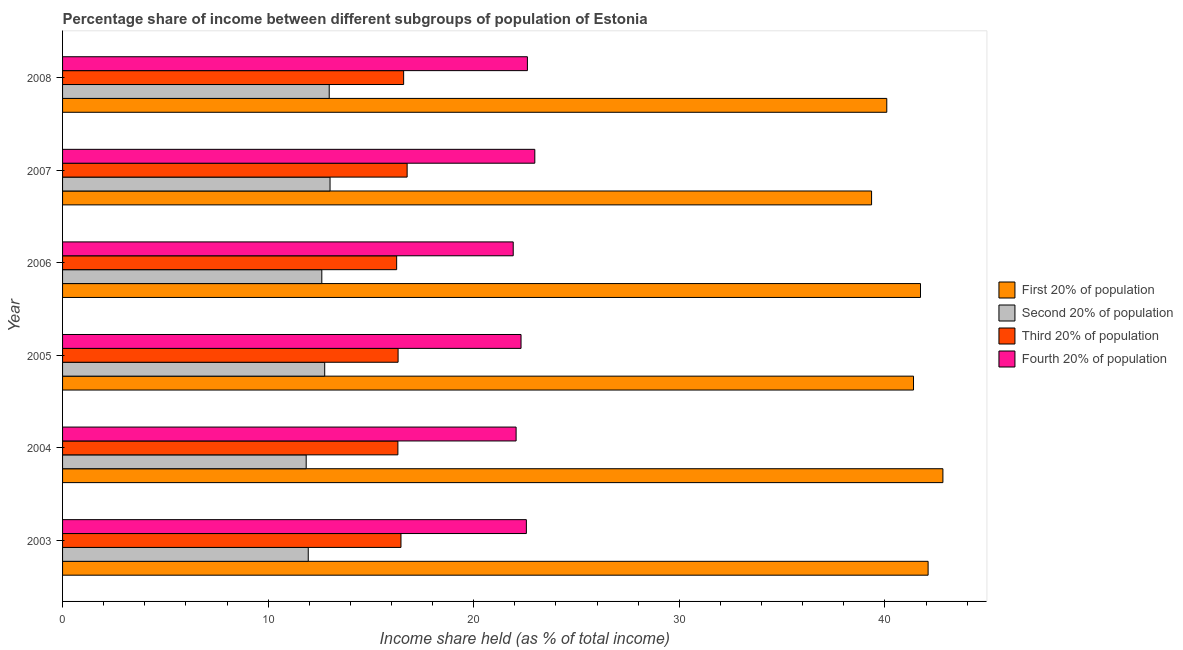Are the number of bars on each tick of the Y-axis equal?
Ensure brevity in your answer.  Yes. How many bars are there on the 1st tick from the top?
Offer a terse response. 4. How many bars are there on the 5th tick from the bottom?
Offer a terse response. 4. What is the label of the 4th group of bars from the top?
Offer a terse response. 2005. In how many cases, is the number of bars for a given year not equal to the number of legend labels?
Offer a very short reply. 0. What is the share of the income held by fourth 20% of the population in 2003?
Your response must be concise. 22.56. Across all years, what is the maximum share of the income held by fourth 20% of the population?
Offer a very short reply. 22.97. Across all years, what is the minimum share of the income held by third 20% of the population?
Make the answer very short. 16.25. In which year was the share of the income held by second 20% of the population maximum?
Your answer should be very brief. 2007. What is the total share of the income held by first 20% of the population in the graph?
Your answer should be compact. 247.48. What is the difference between the share of the income held by first 20% of the population in 2005 and the share of the income held by second 20% of the population in 2004?
Ensure brevity in your answer.  29.54. What is the average share of the income held by second 20% of the population per year?
Your response must be concise. 12.52. In the year 2003, what is the difference between the share of the income held by third 20% of the population and share of the income held by second 20% of the population?
Provide a short and direct response. 4.51. In how many years, is the share of the income held by second 20% of the population greater than 18 %?
Your answer should be very brief. 0. Is the share of the income held by first 20% of the population in 2003 less than that in 2006?
Your answer should be very brief. No. What is the difference between the highest and the second highest share of the income held by second 20% of the population?
Keep it short and to the point. 0.04. What is the difference between the highest and the lowest share of the income held by third 20% of the population?
Ensure brevity in your answer.  0.51. In how many years, is the share of the income held by fourth 20% of the population greater than the average share of the income held by fourth 20% of the population taken over all years?
Offer a very short reply. 3. Is the sum of the share of the income held by second 20% of the population in 2004 and 2005 greater than the maximum share of the income held by first 20% of the population across all years?
Your response must be concise. No. Is it the case that in every year, the sum of the share of the income held by second 20% of the population and share of the income held by first 20% of the population is greater than the sum of share of the income held by fourth 20% of the population and share of the income held by third 20% of the population?
Offer a terse response. Yes. What does the 3rd bar from the top in 2008 represents?
Ensure brevity in your answer.  Second 20% of population. What does the 3rd bar from the bottom in 2006 represents?
Ensure brevity in your answer.  Third 20% of population. Is it the case that in every year, the sum of the share of the income held by first 20% of the population and share of the income held by second 20% of the population is greater than the share of the income held by third 20% of the population?
Your answer should be very brief. Yes. Are the values on the major ticks of X-axis written in scientific E-notation?
Keep it short and to the point. No. Does the graph contain grids?
Provide a short and direct response. No. How many legend labels are there?
Your response must be concise. 4. How are the legend labels stacked?
Give a very brief answer. Vertical. What is the title of the graph?
Offer a terse response. Percentage share of income between different subgroups of population of Estonia. Does "Goods and services" appear as one of the legend labels in the graph?
Your answer should be very brief. No. What is the label or title of the X-axis?
Provide a short and direct response. Income share held (as % of total income). What is the Income share held (as % of total income) in First 20% of population in 2003?
Provide a short and direct response. 42.1. What is the Income share held (as % of total income) in Second 20% of population in 2003?
Make the answer very short. 11.95. What is the Income share held (as % of total income) in Third 20% of population in 2003?
Your answer should be compact. 16.46. What is the Income share held (as % of total income) in Fourth 20% of population in 2003?
Offer a very short reply. 22.56. What is the Income share held (as % of total income) in First 20% of population in 2004?
Your response must be concise. 42.82. What is the Income share held (as % of total income) of Second 20% of population in 2004?
Keep it short and to the point. 11.85. What is the Income share held (as % of total income) in Third 20% of population in 2004?
Provide a short and direct response. 16.31. What is the Income share held (as % of total income) of Fourth 20% of population in 2004?
Offer a very short reply. 22.06. What is the Income share held (as % of total income) in First 20% of population in 2005?
Provide a short and direct response. 41.39. What is the Income share held (as % of total income) of Second 20% of population in 2005?
Make the answer very short. 12.75. What is the Income share held (as % of total income) of Third 20% of population in 2005?
Provide a short and direct response. 16.32. What is the Income share held (as % of total income) in Fourth 20% of population in 2005?
Your response must be concise. 22.3. What is the Income share held (as % of total income) in First 20% of population in 2006?
Your response must be concise. 41.73. What is the Income share held (as % of total income) of Second 20% of population in 2006?
Make the answer very short. 12.61. What is the Income share held (as % of total income) of Third 20% of population in 2006?
Make the answer very short. 16.25. What is the Income share held (as % of total income) of Fourth 20% of population in 2006?
Ensure brevity in your answer.  21.92. What is the Income share held (as % of total income) of First 20% of population in 2007?
Ensure brevity in your answer.  39.35. What is the Income share held (as % of total income) in Second 20% of population in 2007?
Offer a very short reply. 13.01. What is the Income share held (as % of total income) of Third 20% of population in 2007?
Your response must be concise. 16.76. What is the Income share held (as % of total income) in Fourth 20% of population in 2007?
Make the answer very short. 22.97. What is the Income share held (as % of total income) of First 20% of population in 2008?
Give a very brief answer. 40.09. What is the Income share held (as % of total income) in Second 20% of population in 2008?
Keep it short and to the point. 12.97. What is the Income share held (as % of total income) of Third 20% of population in 2008?
Your answer should be compact. 16.59. What is the Income share held (as % of total income) of Fourth 20% of population in 2008?
Provide a succinct answer. 22.61. Across all years, what is the maximum Income share held (as % of total income) in First 20% of population?
Your answer should be very brief. 42.82. Across all years, what is the maximum Income share held (as % of total income) in Second 20% of population?
Ensure brevity in your answer.  13.01. Across all years, what is the maximum Income share held (as % of total income) in Third 20% of population?
Your response must be concise. 16.76. Across all years, what is the maximum Income share held (as % of total income) in Fourth 20% of population?
Ensure brevity in your answer.  22.97. Across all years, what is the minimum Income share held (as % of total income) of First 20% of population?
Ensure brevity in your answer.  39.35. Across all years, what is the minimum Income share held (as % of total income) in Second 20% of population?
Provide a short and direct response. 11.85. Across all years, what is the minimum Income share held (as % of total income) in Third 20% of population?
Ensure brevity in your answer.  16.25. Across all years, what is the minimum Income share held (as % of total income) of Fourth 20% of population?
Keep it short and to the point. 21.92. What is the total Income share held (as % of total income) in First 20% of population in the graph?
Your response must be concise. 247.48. What is the total Income share held (as % of total income) in Second 20% of population in the graph?
Offer a terse response. 75.14. What is the total Income share held (as % of total income) in Third 20% of population in the graph?
Make the answer very short. 98.69. What is the total Income share held (as % of total income) in Fourth 20% of population in the graph?
Your answer should be very brief. 134.42. What is the difference between the Income share held (as % of total income) of First 20% of population in 2003 and that in 2004?
Your response must be concise. -0.72. What is the difference between the Income share held (as % of total income) of Fourth 20% of population in 2003 and that in 2004?
Ensure brevity in your answer.  0.5. What is the difference between the Income share held (as % of total income) of First 20% of population in 2003 and that in 2005?
Give a very brief answer. 0.71. What is the difference between the Income share held (as % of total income) of Second 20% of population in 2003 and that in 2005?
Make the answer very short. -0.8. What is the difference between the Income share held (as % of total income) in Third 20% of population in 2003 and that in 2005?
Make the answer very short. 0.14. What is the difference between the Income share held (as % of total income) of Fourth 20% of population in 2003 and that in 2005?
Offer a very short reply. 0.26. What is the difference between the Income share held (as % of total income) in First 20% of population in 2003 and that in 2006?
Your answer should be very brief. 0.37. What is the difference between the Income share held (as % of total income) of Second 20% of population in 2003 and that in 2006?
Provide a succinct answer. -0.66. What is the difference between the Income share held (as % of total income) in Third 20% of population in 2003 and that in 2006?
Give a very brief answer. 0.21. What is the difference between the Income share held (as % of total income) in Fourth 20% of population in 2003 and that in 2006?
Ensure brevity in your answer.  0.64. What is the difference between the Income share held (as % of total income) of First 20% of population in 2003 and that in 2007?
Make the answer very short. 2.75. What is the difference between the Income share held (as % of total income) in Second 20% of population in 2003 and that in 2007?
Ensure brevity in your answer.  -1.06. What is the difference between the Income share held (as % of total income) in Third 20% of population in 2003 and that in 2007?
Your answer should be very brief. -0.3. What is the difference between the Income share held (as % of total income) in Fourth 20% of population in 2003 and that in 2007?
Your response must be concise. -0.41. What is the difference between the Income share held (as % of total income) of First 20% of population in 2003 and that in 2008?
Your response must be concise. 2.01. What is the difference between the Income share held (as % of total income) in Second 20% of population in 2003 and that in 2008?
Make the answer very short. -1.02. What is the difference between the Income share held (as % of total income) of Third 20% of population in 2003 and that in 2008?
Offer a terse response. -0.13. What is the difference between the Income share held (as % of total income) in First 20% of population in 2004 and that in 2005?
Make the answer very short. 1.43. What is the difference between the Income share held (as % of total income) in Second 20% of population in 2004 and that in 2005?
Offer a very short reply. -0.9. What is the difference between the Income share held (as % of total income) of Third 20% of population in 2004 and that in 2005?
Ensure brevity in your answer.  -0.01. What is the difference between the Income share held (as % of total income) in Fourth 20% of population in 2004 and that in 2005?
Provide a short and direct response. -0.24. What is the difference between the Income share held (as % of total income) in First 20% of population in 2004 and that in 2006?
Provide a succinct answer. 1.09. What is the difference between the Income share held (as % of total income) in Second 20% of population in 2004 and that in 2006?
Your answer should be compact. -0.76. What is the difference between the Income share held (as % of total income) in Third 20% of population in 2004 and that in 2006?
Your response must be concise. 0.06. What is the difference between the Income share held (as % of total income) of Fourth 20% of population in 2004 and that in 2006?
Your response must be concise. 0.14. What is the difference between the Income share held (as % of total income) in First 20% of population in 2004 and that in 2007?
Your answer should be compact. 3.47. What is the difference between the Income share held (as % of total income) of Second 20% of population in 2004 and that in 2007?
Make the answer very short. -1.16. What is the difference between the Income share held (as % of total income) in Third 20% of population in 2004 and that in 2007?
Your answer should be very brief. -0.45. What is the difference between the Income share held (as % of total income) in Fourth 20% of population in 2004 and that in 2007?
Your answer should be very brief. -0.91. What is the difference between the Income share held (as % of total income) in First 20% of population in 2004 and that in 2008?
Your answer should be compact. 2.73. What is the difference between the Income share held (as % of total income) in Second 20% of population in 2004 and that in 2008?
Your response must be concise. -1.12. What is the difference between the Income share held (as % of total income) of Third 20% of population in 2004 and that in 2008?
Make the answer very short. -0.28. What is the difference between the Income share held (as % of total income) of Fourth 20% of population in 2004 and that in 2008?
Ensure brevity in your answer.  -0.55. What is the difference between the Income share held (as % of total income) of First 20% of population in 2005 and that in 2006?
Your answer should be compact. -0.34. What is the difference between the Income share held (as % of total income) in Second 20% of population in 2005 and that in 2006?
Give a very brief answer. 0.14. What is the difference between the Income share held (as % of total income) of Third 20% of population in 2005 and that in 2006?
Your answer should be very brief. 0.07. What is the difference between the Income share held (as % of total income) in Fourth 20% of population in 2005 and that in 2006?
Provide a succinct answer. 0.38. What is the difference between the Income share held (as % of total income) of First 20% of population in 2005 and that in 2007?
Provide a succinct answer. 2.04. What is the difference between the Income share held (as % of total income) in Second 20% of population in 2005 and that in 2007?
Provide a succinct answer. -0.26. What is the difference between the Income share held (as % of total income) of Third 20% of population in 2005 and that in 2007?
Your response must be concise. -0.44. What is the difference between the Income share held (as % of total income) in Fourth 20% of population in 2005 and that in 2007?
Your answer should be compact. -0.67. What is the difference between the Income share held (as % of total income) of First 20% of population in 2005 and that in 2008?
Provide a short and direct response. 1.3. What is the difference between the Income share held (as % of total income) of Second 20% of population in 2005 and that in 2008?
Provide a succinct answer. -0.22. What is the difference between the Income share held (as % of total income) of Third 20% of population in 2005 and that in 2008?
Your response must be concise. -0.27. What is the difference between the Income share held (as % of total income) in Fourth 20% of population in 2005 and that in 2008?
Keep it short and to the point. -0.31. What is the difference between the Income share held (as % of total income) in First 20% of population in 2006 and that in 2007?
Provide a succinct answer. 2.38. What is the difference between the Income share held (as % of total income) in Third 20% of population in 2006 and that in 2007?
Provide a succinct answer. -0.51. What is the difference between the Income share held (as % of total income) in Fourth 20% of population in 2006 and that in 2007?
Ensure brevity in your answer.  -1.05. What is the difference between the Income share held (as % of total income) in First 20% of population in 2006 and that in 2008?
Your response must be concise. 1.64. What is the difference between the Income share held (as % of total income) of Second 20% of population in 2006 and that in 2008?
Your answer should be compact. -0.36. What is the difference between the Income share held (as % of total income) of Third 20% of population in 2006 and that in 2008?
Offer a very short reply. -0.34. What is the difference between the Income share held (as % of total income) in Fourth 20% of population in 2006 and that in 2008?
Your response must be concise. -0.69. What is the difference between the Income share held (as % of total income) of First 20% of population in 2007 and that in 2008?
Provide a short and direct response. -0.74. What is the difference between the Income share held (as % of total income) of Third 20% of population in 2007 and that in 2008?
Provide a short and direct response. 0.17. What is the difference between the Income share held (as % of total income) in Fourth 20% of population in 2007 and that in 2008?
Offer a very short reply. 0.36. What is the difference between the Income share held (as % of total income) of First 20% of population in 2003 and the Income share held (as % of total income) of Second 20% of population in 2004?
Provide a short and direct response. 30.25. What is the difference between the Income share held (as % of total income) of First 20% of population in 2003 and the Income share held (as % of total income) of Third 20% of population in 2004?
Make the answer very short. 25.79. What is the difference between the Income share held (as % of total income) of First 20% of population in 2003 and the Income share held (as % of total income) of Fourth 20% of population in 2004?
Offer a very short reply. 20.04. What is the difference between the Income share held (as % of total income) of Second 20% of population in 2003 and the Income share held (as % of total income) of Third 20% of population in 2004?
Make the answer very short. -4.36. What is the difference between the Income share held (as % of total income) in Second 20% of population in 2003 and the Income share held (as % of total income) in Fourth 20% of population in 2004?
Make the answer very short. -10.11. What is the difference between the Income share held (as % of total income) of Third 20% of population in 2003 and the Income share held (as % of total income) of Fourth 20% of population in 2004?
Give a very brief answer. -5.6. What is the difference between the Income share held (as % of total income) of First 20% of population in 2003 and the Income share held (as % of total income) of Second 20% of population in 2005?
Offer a terse response. 29.35. What is the difference between the Income share held (as % of total income) of First 20% of population in 2003 and the Income share held (as % of total income) of Third 20% of population in 2005?
Your answer should be very brief. 25.78. What is the difference between the Income share held (as % of total income) of First 20% of population in 2003 and the Income share held (as % of total income) of Fourth 20% of population in 2005?
Keep it short and to the point. 19.8. What is the difference between the Income share held (as % of total income) in Second 20% of population in 2003 and the Income share held (as % of total income) in Third 20% of population in 2005?
Ensure brevity in your answer.  -4.37. What is the difference between the Income share held (as % of total income) of Second 20% of population in 2003 and the Income share held (as % of total income) of Fourth 20% of population in 2005?
Provide a succinct answer. -10.35. What is the difference between the Income share held (as % of total income) of Third 20% of population in 2003 and the Income share held (as % of total income) of Fourth 20% of population in 2005?
Make the answer very short. -5.84. What is the difference between the Income share held (as % of total income) of First 20% of population in 2003 and the Income share held (as % of total income) of Second 20% of population in 2006?
Provide a short and direct response. 29.49. What is the difference between the Income share held (as % of total income) of First 20% of population in 2003 and the Income share held (as % of total income) of Third 20% of population in 2006?
Your response must be concise. 25.85. What is the difference between the Income share held (as % of total income) of First 20% of population in 2003 and the Income share held (as % of total income) of Fourth 20% of population in 2006?
Make the answer very short. 20.18. What is the difference between the Income share held (as % of total income) in Second 20% of population in 2003 and the Income share held (as % of total income) in Fourth 20% of population in 2006?
Your answer should be compact. -9.97. What is the difference between the Income share held (as % of total income) of Third 20% of population in 2003 and the Income share held (as % of total income) of Fourth 20% of population in 2006?
Provide a succinct answer. -5.46. What is the difference between the Income share held (as % of total income) in First 20% of population in 2003 and the Income share held (as % of total income) in Second 20% of population in 2007?
Offer a very short reply. 29.09. What is the difference between the Income share held (as % of total income) of First 20% of population in 2003 and the Income share held (as % of total income) of Third 20% of population in 2007?
Offer a terse response. 25.34. What is the difference between the Income share held (as % of total income) of First 20% of population in 2003 and the Income share held (as % of total income) of Fourth 20% of population in 2007?
Give a very brief answer. 19.13. What is the difference between the Income share held (as % of total income) of Second 20% of population in 2003 and the Income share held (as % of total income) of Third 20% of population in 2007?
Your answer should be compact. -4.81. What is the difference between the Income share held (as % of total income) of Second 20% of population in 2003 and the Income share held (as % of total income) of Fourth 20% of population in 2007?
Keep it short and to the point. -11.02. What is the difference between the Income share held (as % of total income) in Third 20% of population in 2003 and the Income share held (as % of total income) in Fourth 20% of population in 2007?
Provide a short and direct response. -6.51. What is the difference between the Income share held (as % of total income) of First 20% of population in 2003 and the Income share held (as % of total income) of Second 20% of population in 2008?
Give a very brief answer. 29.13. What is the difference between the Income share held (as % of total income) in First 20% of population in 2003 and the Income share held (as % of total income) in Third 20% of population in 2008?
Provide a succinct answer. 25.51. What is the difference between the Income share held (as % of total income) of First 20% of population in 2003 and the Income share held (as % of total income) of Fourth 20% of population in 2008?
Make the answer very short. 19.49. What is the difference between the Income share held (as % of total income) of Second 20% of population in 2003 and the Income share held (as % of total income) of Third 20% of population in 2008?
Offer a terse response. -4.64. What is the difference between the Income share held (as % of total income) in Second 20% of population in 2003 and the Income share held (as % of total income) in Fourth 20% of population in 2008?
Ensure brevity in your answer.  -10.66. What is the difference between the Income share held (as % of total income) of Third 20% of population in 2003 and the Income share held (as % of total income) of Fourth 20% of population in 2008?
Keep it short and to the point. -6.15. What is the difference between the Income share held (as % of total income) in First 20% of population in 2004 and the Income share held (as % of total income) in Second 20% of population in 2005?
Provide a succinct answer. 30.07. What is the difference between the Income share held (as % of total income) in First 20% of population in 2004 and the Income share held (as % of total income) in Third 20% of population in 2005?
Your answer should be very brief. 26.5. What is the difference between the Income share held (as % of total income) of First 20% of population in 2004 and the Income share held (as % of total income) of Fourth 20% of population in 2005?
Keep it short and to the point. 20.52. What is the difference between the Income share held (as % of total income) of Second 20% of population in 2004 and the Income share held (as % of total income) of Third 20% of population in 2005?
Make the answer very short. -4.47. What is the difference between the Income share held (as % of total income) in Second 20% of population in 2004 and the Income share held (as % of total income) in Fourth 20% of population in 2005?
Ensure brevity in your answer.  -10.45. What is the difference between the Income share held (as % of total income) of Third 20% of population in 2004 and the Income share held (as % of total income) of Fourth 20% of population in 2005?
Keep it short and to the point. -5.99. What is the difference between the Income share held (as % of total income) of First 20% of population in 2004 and the Income share held (as % of total income) of Second 20% of population in 2006?
Ensure brevity in your answer.  30.21. What is the difference between the Income share held (as % of total income) of First 20% of population in 2004 and the Income share held (as % of total income) of Third 20% of population in 2006?
Ensure brevity in your answer.  26.57. What is the difference between the Income share held (as % of total income) of First 20% of population in 2004 and the Income share held (as % of total income) of Fourth 20% of population in 2006?
Give a very brief answer. 20.9. What is the difference between the Income share held (as % of total income) in Second 20% of population in 2004 and the Income share held (as % of total income) in Fourth 20% of population in 2006?
Your response must be concise. -10.07. What is the difference between the Income share held (as % of total income) in Third 20% of population in 2004 and the Income share held (as % of total income) in Fourth 20% of population in 2006?
Ensure brevity in your answer.  -5.61. What is the difference between the Income share held (as % of total income) in First 20% of population in 2004 and the Income share held (as % of total income) in Second 20% of population in 2007?
Keep it short and to the point. 29.81. What is the difference between the Income share held (as % of total income) of First 20% of population in 2004 and the Income share held (as % of total income) of Third 20% of population in 2007?
Provide a succinct answer. 26.06. What is the difference between the Income share held (as % of total income) of First 20% of population in 2004 and the Income share held (as % of total income) of Fourth 20% of population in 2007?
Keep it short and to the point. 19.85. What is the difference between the Income share held (as % of total income) of Second 20% of population in 2004 and the Income share held (as % of total income) of Third 20% of population in 2007?
Ensure brevity in your answer.  -4.91. What is the difference between the Income share held (as % of total income) of Second 20% of population in 2004 and the Income share held (as % of total income) of Fourth 20% of population in 2007?
Offer a terse response. -11.12. What is the difference between the Income share held (as % of total income) in Third 20% of population in 2004 and the Income share held (as % of total income) in Fourth 20% of population in 2007?
Your response must be concise. -6.66. What is the difference between the Income share held (as % of total income) in First 20% of population in 2004 and the Income share held (as % of total income) in Second 20% of population in 2008?
Offer a terse response. 29.85. What is the difference between the Income share held (as % of total income) of First 20% of population in 2004 and the Income share held (as % of total income) of Third 20% of population in 2008?
Your response must be concise. 26.23. What is the difference between the Income share held (as % of total income) of First 20% of population in 2004 and the Income share held (as % of total income) of Fourth 20% of population in 2008?
Your answer should be compact. 20.21. What is the difference between the Income share held (as % of total income) of Second 20% of population in 2004 and the Income share held (as % of total income) of Third 20% of population in 2008?
Ensure brevity in your answer.  -4.74. What is the difference between the Income share held (as % of total income) in Second 20% of population in 2004 and the Income share held (as % of total income) in Fourth 20% of population in 2008?
Ensure brevity in your answer.  -10.76. What is the difference between the Income share held (as % of total income) in First 20% of population in 2005 and the Income share held (as % of total income) in Second 20% of population in 2006?
Provide a short and direct response. 28.78. What is the difference between the Income share held (as % of total income) in First 20% of population in 2005 and the Income share held (as % of total income) in Third 20% of population in 2006?
Offer a terse response. 25.14. What is the difference between the Income share held (as % of total income) in First 20% of population in 2005 and the Income share held (as % of total income) in Fourth 20% of population in 2006?
Ensure brevity in your answer.  19.47. What is the difference between the Income share held (as % of total income) in Second 20% of population in 2005 and the Income share held (as % of total income) in Third 20% of population in 2006?
Your answer should be compact. -3.5. What is the difference between the Income share held (as % of total income) in Second 20% of population in 2005 and the Income share held (as % of total income) in Fourth 20% of population in 2006?
Make the answer very short. -9.17. What is the difference between the Income share held (as % of total income) in Third 20% of population in 2005 and the Income share held (as % of total income) in Fourth 20% of population in 2006?
Ensure brevity in your answer.  -5.6. What is the difference between the Income share held (as % of total income) of First 20% of population in 2005 and the Income share held (as % of total income) of Second 20% of population in 2007?
Keep it short and to the point. 28.38. What is the difference between the Income share held (as % of total income) of First 20% of population in 2005 and the Income share held (as % of total income) of Third 20% of population in 2007?
Keep it short and to the point. 24.63. What is the difference between the Income share held (as % of total income) in First 20% of population in 2005 and the Income share held (as % of total income) in Fourth 20% of population in 2007?
Your response must be concise. 18.42. What is the difference between the Income share held (as % of total income) in Second 20% of population in 2005 and the Income share held (as % of total income) in Third 20% of population in 2007?
Make the answer very short. -4.01. What is the difference between the Income share held (as % of total income) in Second 20% of population in 2005 and the Income share held (as % of total income) in Fourth 20% of population in 2007?
Provide a succinct answer. -10.22. What is the difference between the Income share held (as % of total income) of Third 20% of population in 2005 and the Income share held (as % of total income) of Fourth 20% of population in 2007?
Your response must be concise. -6.65. What is the difference between the Income share held (as % of total income) of First 20% of population in 2005 and the Income share held (as % of total income) of Second 20% of population in 2008?
Your answer should be compact. 28.42. What is the difference between the Income share held (as % of total income) in First 20% of population in 2005 and the Income share held (as % of total income) in Third 20% of population in 2008?
Your answer should be compact. 24.8. What is the difference between the Income share held (as % of total income) of First 20% of population in 2005 and the Income share held (as % of total income) of Fourth 20% of population in 2008?
Provide a succinct answer. 18.78. What is the difference between the Income share held (as % of total income) of Second 20% of population in 2005 and the Income share held (as % of total income) of Third 20% of population in 2008?
Offer a very short reply. -3.84. What is the difference between the Income share held (as % of total income) of Second 20% of population in 2005 and the Income share held (as % of total income) of Fourth 20% of population in 2008?
Keep it short and to the point. -9.86. What is the difference between the Income share held (as % of total income) in Third 20% of population in 2005 and the Income share held (as % of total income) in Fourth 20% of population in 2008?
Provide a succinct answer. -6.29. What is the difference between the Income share held (as % of total income) in First 20% of population in 2006 and the Income share held (as % of total income) in Second 20% of population in 2007?
Offer a very short reply. 28.72. What is the difference between the Income share held (as % of total income) of First 20% of population in 2006 and the Income share held (as % of total income) of Third 20% of population in 2007?
Your answer should be very brief. 24.97. What is the difference between the Income share held (as % of total income) of First 20% of population in 2006 and the Income share held (as % of total income) of Fourth 20% of population in 2007?
Your answer should be very brief. 18.76. What is the difference between the Income share held (as % of total income) in Second 20% of population in 2006 and the Income share held (as % of total income) in Third 20% of population in 2007?
Offer a very short reply. -4.15. What is the difference between the Income share held (as % of total income) of Second 20% of population in 2006 and the Income share held (as % of total income) of Fourth 20% of population in 2007?
Keep it short and to the point. -10.36. What is the difference between the Income share held (as % of total income) in Third 20% of population in 2006 and the Income share held (as % of total income) in Fourth 20% of population in 2007?
Keep it short and to the point. -6.72. What is the difference between the Income share held (as % of total income) in First 20% of population in 2006 and the Income share held (as % of total income) in Second 20% of population in 2008?
Keep it short and to the point. 28.76. What is the difference between the Income share held (as % of total income) of First 20% of population in 2006 and the Income share held (as % of total income) of Third 20% of population in 2008?
Keep it short and to the point. 25.14. What is the difference between the Income share held (as % of total income) of First 20% of population in 2006 and the Income share held (as % of total income) of Fourth 20% of population in 2008?
Provide a succinct answer. 19.12. What is the difference between the Income share held (as % of total income) in Second 20% of population in 2006 and the Income share held (as % of total income) in Third 20% of population in 2008?
Give a very brief answer. -3.98. What is the difference between the Income share held (as % of total income) in Second 20% of population in 2006 and the Income share held (as % of total income) in Fourth 20% of population in 2008?
Provide a short and direct response. -10. What is the difference between the Income share held (as % of total income) of Third 20% of population in 2006 and the Income share held (as % of total income) of Fourth 20% of population in 2008?
Your answer should be compact. -6.36. What is the difference between the Income share held (as % of total income) in First 20% of population in 2007 and the Income share held (as % of total income) in Second 20% of population in 2008?
Ensure brevity in your answer.  26.38. What is the difference between the Income share held (as % of total income) in First 20% of population in 2007 and the Income share held (as % of total income) in Third 20% of population in 2008?
Give a very brief answer. 22.76. What is the difference between the Income share held (as % of total income) in First 20% of population in 2007 and the Income share held (as % of total income) in Fourth 20% of population in 2008?
Offer a very short reply. 16.74. What is the difference between the Income share held (as % of total income) of Second 20% of population in 2007 and the Income share held (as % of total income) of Third 20% of population in 2008?
Provide a succinct answer. -3.58. What is the difference between the Income share held (as % of total income) of Second 20% of population in 2007 and the Income share held (as % of total income) of Fourth 20% of population in 2008?
Provide a succinct answer. -9.6. What is the difference between the Income share held (as % of total income) in Third 20% of population in 2007 and the Income share held (as % of total income) in Fourth 20% of population in 2008?
Your answer should be very brief. -5.85. What is the average Income share held (as % of total income) of First 20% of population per year?
Your answer should be very brief. 41.25. What is the average Income share held (as % of total income) of Second 20% of population per year?
Make the answer very short. 12.52. What is the average Income share held (as % of total income) in Third 20% of population per year?
Your answer should be compact. 16.45. What is the average Income share held (as % of total income) of Fourth 20% of population per year?
Ensure brevity in your answer.  22.4. In the year 2003, what is the difference between the Income share held (as % of total income) of First 20% of population and Income share held (as % of total income) of Second 20% of population?
Offer a very short reply. 30.15. In the year 2003, what is the difference between the Income share held (as % of total income) of First 20% of population and Income share held (as % of total income) of Third 20% of population?
Your response must be concise. 25.64. In the year 2003, what is the difference between the Income share held (as % of total income) of First 20% of population and Income share held (as % of total income) of Fourth 20% of population?
Provide a succinct answer. 19.54. In the year 2003, what is the difference between the Income share held (as % of total income) in Second 20% of population and Income share held (as % of total income) in Third 20% of population?
Give a very brief answer. -4.51. In the year 2003, what is the difference between the Income share held (as % of total income) in Second 20% of population and Income share held (as % of total income) in Fourth 20% of population?
Your answer should be very brief. -10.61. In the year 2004, what is the difference between the Income share held (as % of total income) of First 20% of population and Income share held (as % of total income) of Second 20% of population?
Offer a terse response. 30.97. In the year 2004, what is the difference between the Income share held (as % of total income) of First 20% of population and Income share held (as % of total income) of Third 20% of population?
Your answer should be compact. 26.51. In the year 2004, what is the difference between the Income share held (as % of total income) of First 20% of population and Income share held (as % of total income) of Fourth 20% of population?
Your answer should be compact. 20.76. In the year 2004, what is the difference between the Income share held (as % of total income) in Second 20% of population and Income share held (as % of total income) in Third 20% of population?
Your response must be concise. -4.46. In the year 2004, what is the difference between the Income share held (as % of total income) in Second 20% of population and Income share held (as % of total income) in Fourth 20% of population?
Your answer should be compact. -10.21. In the year 2004, what is the difference between the Income share held (as % of total income) in Third 20% of population and Income share held (as % of total income) in Fourth 20% of population?
Give a very brief answer. -5.75. In the year 2005, what is the difference between the Income share held (as % of total income) of First 20% of population and Income share held (as % of total income) of Second 20% of population?
Offer a terse response. 28.64. In the year 2005, what is the difference between the Income share held (as % of total income) of First 20% of population and Income share held (as % of total income) of Third 20% of population?
Offer a very short reply. 25.07. In the year 2005, what is the difference between the Income share held (as % of total income) in First 20% of population and Income share held (as % of total income) in Fourth 20% of population?
Offer a terse response. 19.09. In the year 2005, what is the difference between the Income share held (as % of total income) of Second 20% of population and Income share held (as % of total income) of Third 20% of population?
Offer a very short reply. -3.57. In the year 2005, what is the difference between the Income share held (as % of total income) of Second 20% of population and Income share held (as % of total income) of Fourth 20% of population?
Your answer should be compact. -9.55. In the year 2005, what is the difference between the Income share held (as % of total income) of Third 20% of population and Income share held (as % of total income) of Fourth 20% of population?
Provide a short and direct response. -5.98. In the year 2006, what is the difference between the Income share held (as % of total income) of First 20% of population and Income share held (as % of total income) of Second 20% of population?
Your response must be concise. 29.12. In the year 2006, what is the difference between the Income share held (as % of total income) of First 20% of population and Income share held (as % of total income) of Third 20% of population?
Your response must be concise. 25.48. In the year 2006, what is the difference between the Income share held (as % of total income) of First 20% of population and Income share held (as % of total income) of Fourth 20% of population?
Give a very brief answer. 19.81. In the year 2006, what is the difference between the Income share held (as % of total income) in Second 20% of population and Income share held (as % of total income) in Third 20% of population?
Provide a succinct answer. -3.64. In the year 2006, what is the difference between the Income share held (as % of total income) of Second 20% of population and Income share held (as % of total income) of Fourth 20% of population?
Your answer should be very brief. -9.31. In the year 2006, what is the difference between the Income share held (as % of total income) in Third 20% of population and Income share held (as % of total income) in Fourth 20% of population?
Make the answer very short. -5.67. In the year 2007, what is the difference between the Income share held (as % of total income) of First 20% of population and Income share held (as % of total income) of Second 20% of population?
Offer a terse response. 26.34. In the year 2007, what is the difference between the Income share held (as % of total income) in First 20% of population and Income share held (as % of total income) in Third 20% of population?
Your answer should be very brief. 22.59. In the year 2007, what is the difference between the Income share held (as % of total income) of First 20% of population and Income share held (as % of total income) of Fourth 20% of population?
Keep it short and to the point. 16.38. In the year 2007, what is the difference between the Income share held (as % of total income) in Second 20% of population and Income share held (as % of total income) in Third 20% of population?
Your response must be concise. -3.75. In the year 2007, what is the difference between the Income share held (as % of total income) in Second 20% of population and Income share held (as % of total income) in Fourth 20% of population?
Your answer should be compact. -9.96. In the year 2007, what is the difference between the Income share held (as % of total income) of Third 20% of population and Income share held (as % of total income) of Fourth 20% of population?
Provide a succinct answer. -6.21. In the year 2008, what is the difference between the Income share held (as % of total income) of First 20% of population and Income share held (as % of total income) of Second 20% of population?
Offer a terse response. 27.12. In the year 2008, what is the difference between the Income share held (as % of total income) of First 20% of population and Income share held (as % of total income) of Fourth 20% of population?
Make the answer very short. 17.48. In the year 2008, what is the difference between the Income share held (as % of total income) of Second 20% of population and Income share held (as % of total income) of Third 20% of population?
Your answer should be compact. -3.62. In the year 2008, what is the difference between the Income share held (as % of total income) of Second 20% of population and Income share held (as % of total income) of Fourth 20% of population?
Offer a terse response. -9.64. In the year 2008, what is the difference between the Income share held (as % of total income) in Third 20% of population and Income share held (as % of total income) in Fourth 20% of population?
Provide a short and direct response. -6.02. What is the ratio of the Income share held (as % of total income) of First 20% of population in 2003 to that in 2004?
Provide a short and direct response. 0.98. What is the ratio of the Income share held (as % of total income) of Second 20% of population in 2003 to that in 2004?
Your response must be concise. 1.01. What is the ratio of the Income share held (as % of total income) in Third 20% of population in 2003 to that in 2004?
Ensure brevity in your answer.  1.01. What is the ratio of the Income share held (as % of total income) of Fourth 20% of population in 2003 to that in 2004?
Provide a short and direct response. 1.02. What is the ratio of the Income share held (as % of total income) in First 20% of population in 2003 to that in 2005?
Provide a succinct answer. 1.02. What is the ratio of the Income share held (as % of total income) of Second 20% of population in 2003 to that in 2005?
Keep it short and to the point. 0.94. What is the ratio of the Income share held (as % of total income) in Third 20% of population in 2003 to that in 2005?
Keep it short and to the point. 1.01. What is the ratio of the Income share held (as % of total income) in Fourth 20% of population in 2003 to that in 2005?
Your answer should be very brief. 1.01. What is the ratio of the Income share held (as % of total income) in First 20% of population in 2003 to that in 2006?
Your response must be concise. 1.01. What is the ratio of the Income share held (as % of total income) of Second 20% of population in 2003 to that in 2006?
Provide a succinct answer. 0.95. What is the ratio of the Income share held (as % of total income) of Third 20% of population in 2003 to that in 2006?
Provide a short and direct response. 1.01. What is the ratio of the Income share held (as % of total income) in Fourth 20% of population in 2003 to that in 2006?
Offer a terse response. 1.03. What is the ratio of the Income share held (as % of total income) in First 20% of population in 2003 to that in 2007?
Your answer should be compact. 1.07. What is the ratio of the Income share held (as % of total income) of Second 20% of population in 2003 to that in 2007?
Provide a succinct answer. 0.92. What is the ratio of the Income share held (as % of total income) in Third 20% of population in 2003 to that in 2007?
Offer a terse response. 0.98. What is the ratio of the Income share held (as % of total income) of Fourth 20% of population in 2003 to that in 2007?
Provide a succinct answer. 0.98. What is the ratio of the Income share held (as % of total income) in First 20% of population in 2003 to that in 2008?
Offer a terse response. 1.05. What is the ratio of the Income share held (as % of total income) in Second 20% of population in 2003 to that in 2008?
Provide a succinct answer. 0.92. What is the ratio of the Income share held (as % of total income) in Third 20% of population in 2003 to that in 2008?
Provide a short and direct response. 0.99. What is the ratio of the Income share held (as % of total income) in First 20% of population in 2004 to that in 2005?
Provide a short and direct response. 1.03. What is the ratio of the Income share held (as % of total income) in Second 20% of population in 2004 to that in 2005?
Give a very brief answer. 0.93. What is the ratio of the Income share held (as % of total income) of Fourth 20% of population in 2004 to that in 2005?
Make the answer very short. 0.99. What is the ratio of the Income share held (as % of total income) in First 20% of population in 2004 to that in 2006?
Provide a succinct answer. 1.03. What is the ratio of the Income share held (as % of total income) in Second 20% of population in 2004 to that in 2006?
Your answer should be very brief. 0.94. What is the ratio of the Income share held (as % of total income) of Third 20% of population in 2004 to that in 2006?
Offer a very short reply. 1. What is the ratio of the Income share held (as % of total income) in Fourth 20% of population in 2004 to that in 2006?
Offer a terse response. 1.01. What is the ratio of the Income share held (as % of total income) of First 20% of population in 2004 to that in 2007?
Keep it short and to the point. 1.09. What is the ratio of the Income share held (as % of total income) in Second 20% of population in 2004 to that in 2007?
Provide a succinct answer. 0.91. What is the ratio of the Income share held (as % of total income) in Third 20% of population in 2004 to that in 2007?
Provide a succinct answer. 0.97. What is the ratio of the Income share held (as % of total income) in Fourth 20% of population in 2004 to that in 2007?
Provide a short and direct response. 0.96. What is the ratio of the Income share held (as % of total income) of First 20% of population in 2004 to that in 2008?
Offer a terse response. 1.07. What is the ratio of the Income share held (as % of total income) of Second 20% of population in 2004 to that in 2008?
Your response must be concise. 0.91. What is the ratio of the Income share held (as % of total income) of Third 20% of population in 2004 to that in 2008?
Make the answer very short. 0.98. What is the ratio of the Income share held (as % of total income) in Fourth 20% of population in 2004 to that in 2008?
Give a very brief answer. 0.98. What is the ratio of the Income share held (as % of total income) of First 20% of population in 2005 to that in 2006?
Offer a very short reply. 0.99. What is the ratio of the Income share held (as % of total income) in Second 20% of population in 2005 to that in 2006?
Your answer should be very brief. 1.01. What is the ratio of the Income share held (as % of total income) of Third 20% of population in 2005 to that in 2006?
Offer a very short reply. 1. What is the ratio of the Income share held (as % of total income) of Fourth 20% of population in 2005 to that in 2006?
Offer a very short reply. 1.02. What is the ratio of the Income share held (as % of total income) of First 20% of population in 2005 to that in 2007?
Ensure brevity in your answer.  1.05. What is the ratio of the Income share held (as % of total income) in Second 20% of population in 2005 to that in 2007?
Give a very brief answer. 0.98. What is the ratio of the Income share held (as % of total income) of Third 20% of population in 2005 to that in 2007?
Provide a short and direct response. 0.97. What is the ratio of the Income share held (as % of total income) of Fourth 20% of population in 2005 to that in 2007?
Make the answer very short. 0.97. What is the ratio of the Income share held (as % of total income) in First 20% of population in 2005 to that in 2008?
Your answer should be very brief. 1.03. What is the ratio of the Income share held (as % of total income) in Third 20% of population in 2005 to that in 2008?
Keep it short and to the point. 0.98. What is the ratio of the Income share held (as % of total income) in Fourth 20% of population in 2005 to that in 2008?
Your answer should be compact. 0.99. What is the ratio of the Income share held (as % of total income) in First 20% of population in 2006 to that in 2007?
Your answer should be compact. 1.06. What is the ratio of the Income share held (as % of total income) in Second 20% of population in 2006 to that in 2007?
Your answer should be very brief. 0.97. What is the ratio of the Income share held (as % of total income) of Third 20% of population in 2006 to that in 2007?
Your answer should be very brief. 0.97. What is the ratio of the Income share held (as % of total income) of Fourth 20% of population in 2006 to that in 2007?
Your answer should be very brief. 0.95. What is the ratio of the Income share held (as % of total income) in First 20% of population in 2006 to that in 2008?
Provide a short and direct response. 1.04. What is the ratio of the Income share held (as % of total income) of Second 20% of population in 2006 to that in 2008?
Keep it short and to the point. 0.97. What is the ratio of the Income share held (as % of total income) of Third 20% of population in 2006 to that in 2008?
Make the answer very short. 0.98. What is the ratio of the Income share held (as % of total income) in Fourth 20% of population in 2006 to that in 2008?
Offer a very short reply. 0.97. What is the ratio of the Income share held (as % of total income) in First 20% of population in 2007 to that in 2008?
Offer a very short reply. 0.98. What is the ratio of the Income share held (as % of total income) of Third 20% of population in 2007 to that in 2008?
Make the answer very short. 1.01. What is the ratio of the Income share held (as % of total income) in Fourth 20% of population in 2007 to that in 2008?
Provide a short and direct response. 1.02. What is the difference between the highest and the second highest Income share held (as % of total income) in First 20% of population?
Your answer should be very brief. 0.72. What is the difference between the highest and the second highest Income share held (as % of total income) of Third 20% of population?
Offer a very short reply. 0.17. What is the difference between the highest and the second highest Income share held (as % of total income) of Fourth 20% of population?
Make the answer very short. 0.36. What is the difference between the highest and the lowest Income share held (as % of total income) in First 20% of population?
Provide a short and direct response. 3.47. What is the difference between the highest and the lowest Income share held (as % of total income) in Second 20% of population?
Offer a terse response. 1.16. What is the difference between the highest and the lowest Income share held (as % of total income) of Third 20% of population?
Your answer should be very brief. 0.51. What is the difference between the highest and the lowest Income share held (as % of total income) of Fourth 20% of population?
Keep it short and to the point. 1.05. 